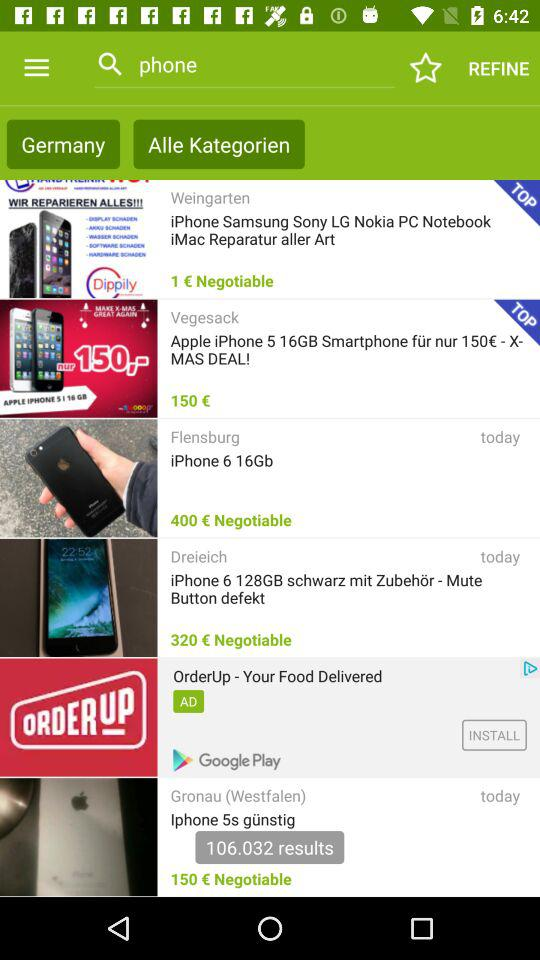How many items have a price of less than 200 euros?
Answer the question using a single word or phrase. 3 